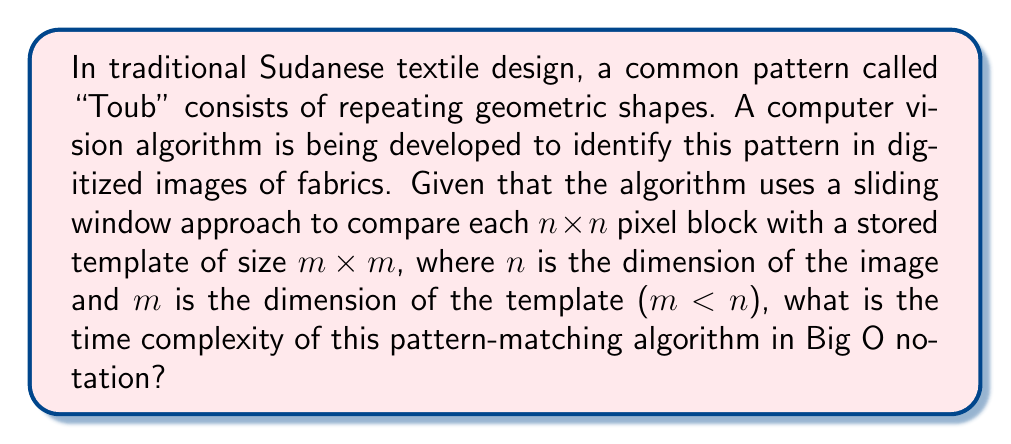Could you help me with this problem? To analyze the time complexity of this pattern-matching algorithm, we need to consider the following steps:

1. The algorithm uses a sliding window approach, which means it needs to check every possible position in the image where the template could match.

2. For an n×n image and an m×m template, the number of possible positions to check is $(n-m+1)^2$. This is because the top-left corner of the template can be placed at any position from (0,0) to (n-m,n-m) in the image.

3. At each position, the algorithm needs to compare the m×m template with the corresponding m×m block in the image. This comparison requires $m^2$ operations.

4. Therefore, the total number of operations is:

   $$(n-m+1)^2 \cdot m^2$$

5. Since m < n, we can simplify this expression for Big O notation. The worst-case scenario (upper bound) would be when m is close to n, so we can approximate $(n-m+1)^2$ as $O(n^2)$.

6. This gives us:

   $$O(n^2 \cdot m^2)$$

7. In Big O notation, we typically express complexity in terms of the largest input size, which in this case is n. Since m < n, we can replace $m^2$ with $n^2$ to get an upper bound:

   $$O(n^2 \cdot n^2) = O(n^4)$$

This analysis shows that the time complexity grows rapidly with the size of the image, which is typical for brute-force pattern matching algorithms.
Answer: $O(n^4)$ 